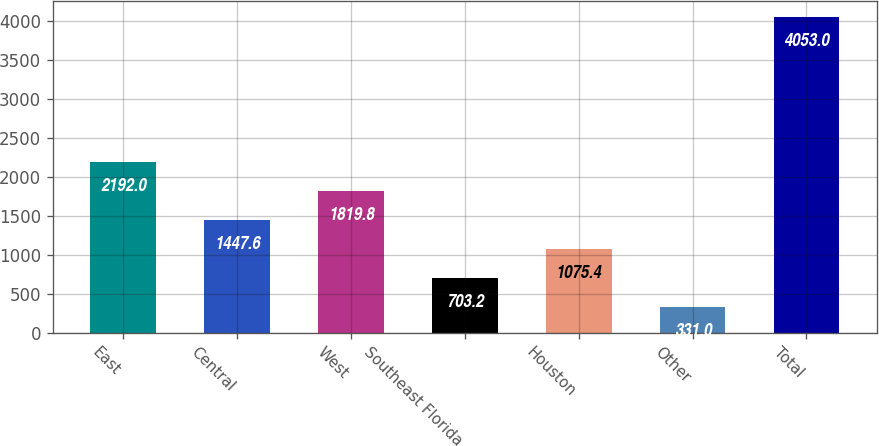Convert chart. <chart><loc_0><loc_0><loc_500><loc_500><bar_chart><fcel>East<fcel>Central<fcel>West<fcel>Southeast Florida<fcel>Houston<fcel>Other<fcel>Total<nl><fcel>2192<fcel>1447.6<fcel>1819.8<fcel>703.2<fcel>1075.4<fcel>331<fcel>4053<nl></chart> 